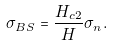Convert formula to latex. <formula><loc_0><loc_0><loc_500><loc_500>\sigma _ { B S } = \frac { H _ { c 2 } } { H } \sigma _ { n } .</formula> 